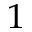Convert formula to latex. <formula><loc_0><loc_0><loc_500><loc_500>^ { 1 }</formula> 